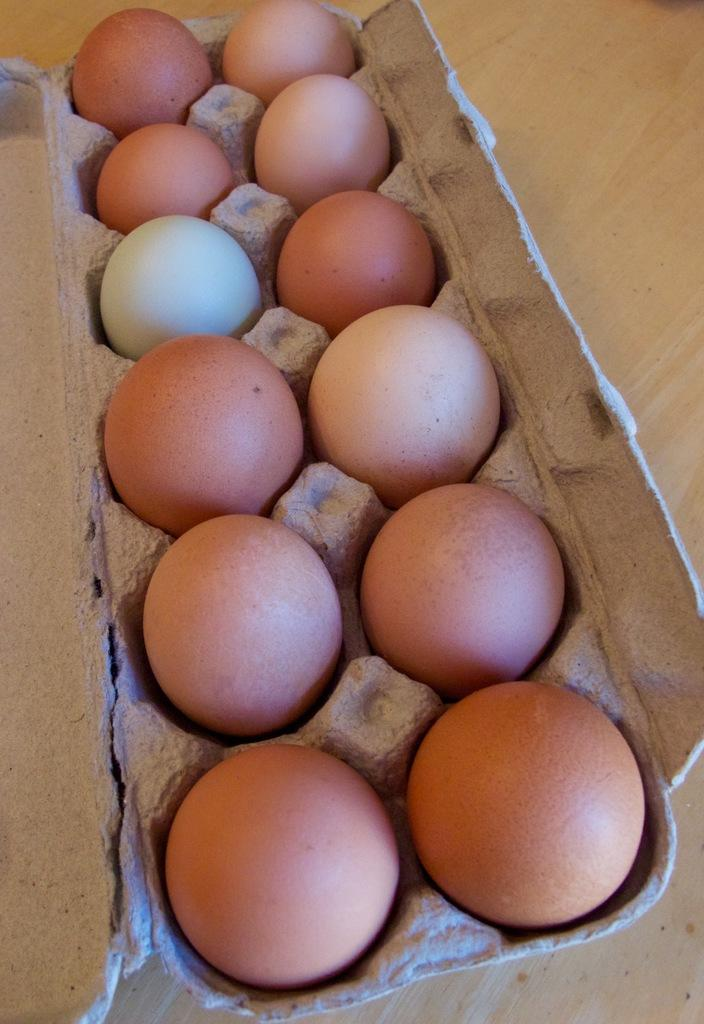What object is present at the bottom of the image? There is a tray in the image, located at the bottom. What is on the tray? The provided facts do not mention what is on the tray. Where are the eggs located in the image? The eggs are in the tree. What company is providing support to the tree in the image? There is no company or support structure mentioned in the image. The tree is standing on its own. 